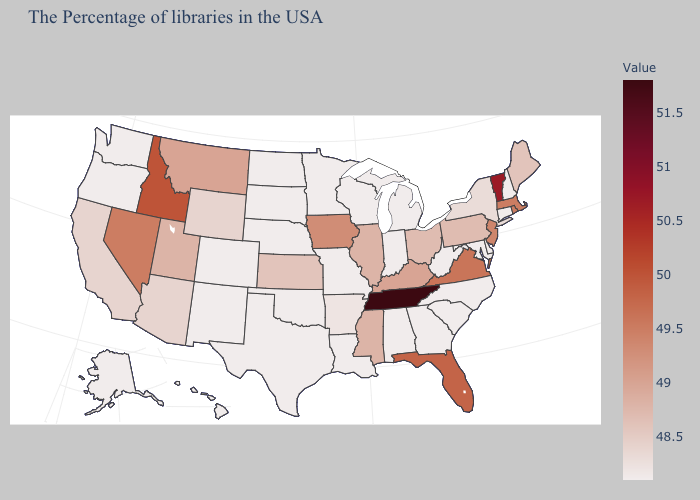Is the legend a continuous bar?
Short answer required. Yes. Does the map have missing data?
Give a very brief answer. No. Does Maine have a higher value than Massachusetts?
Write a very short answer. No. Does Tennessee have the highest value in the USA?
Give a very brief answer. Yes. Which states have the highest value in the USA?
Give a very brief answer. Tennessee. Is the legend a continuous bar?
Answer briefly. Yes. Does Alaska have a lower value than Florida?
Answer briefly. Yes. 